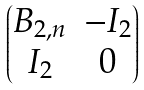<formula> <loc_0><loc_0><loc_500><loc_500>\begin{pmatrix} B _ { 2 , n } & - I _ { 2 } \\ I _ { 2 } & 0 \end{pmatrix}</formula> 